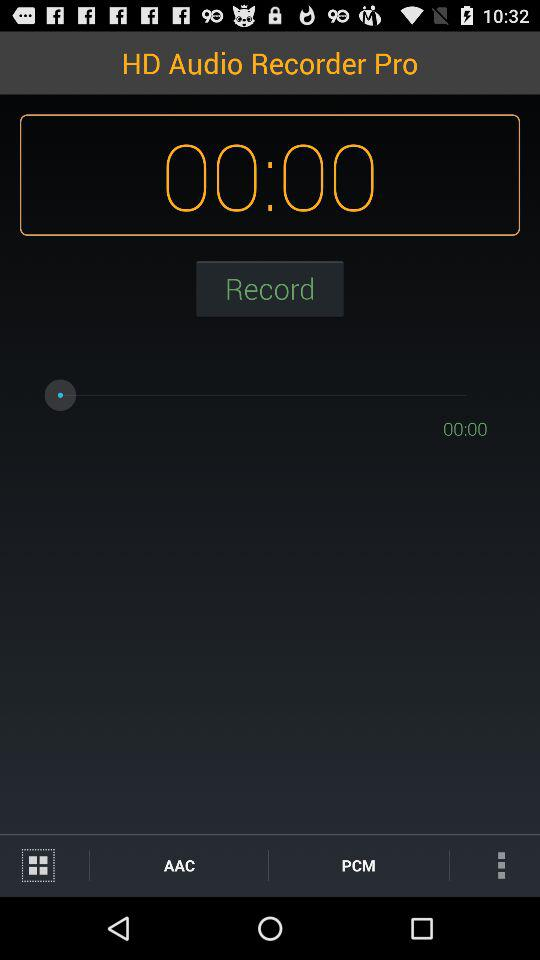What is the application name? The application name is "HD Audio Recorder Pro". 